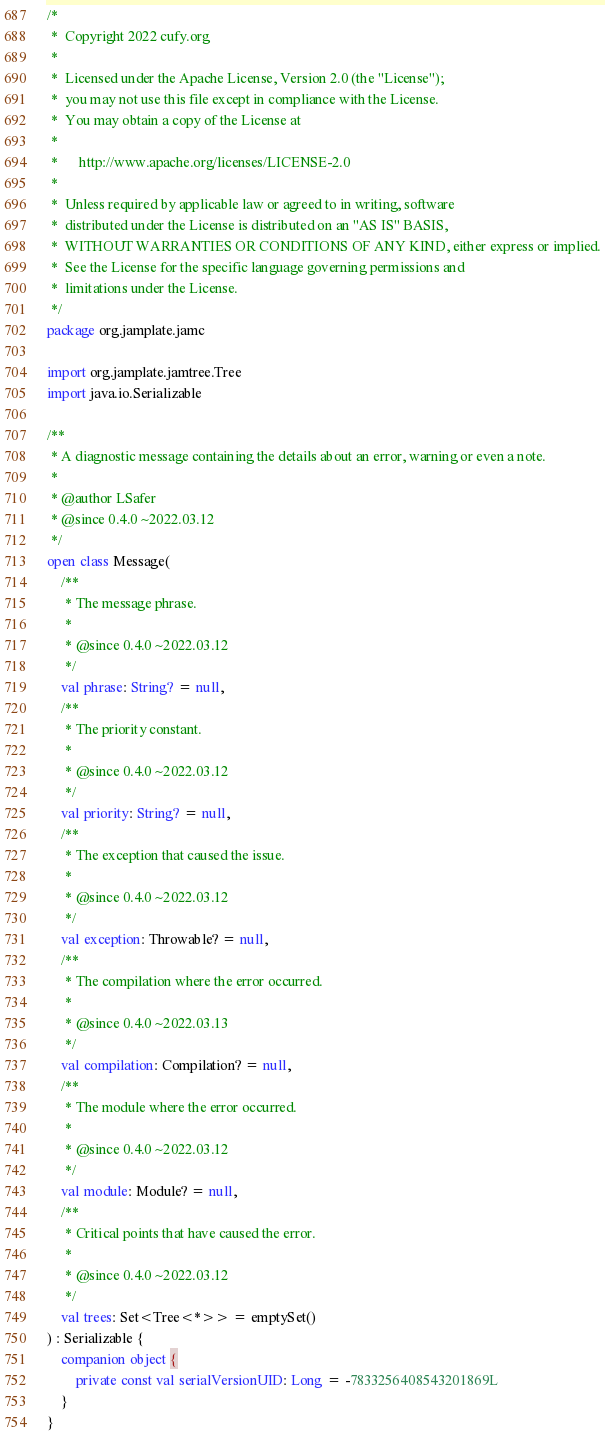<code> <loc_0><loc_0><loc_500><loc_500><_Kotlin_>/*
 *	Copyright 2022 cufy.org
 *
 *	Licensed under the Apache License, Version 2.0 (the "License");
 *	you may not use this file except in compliance with the License.
 *	You may obtain a copy of the License at
 *
 *	    http://www.apache.org/licenses/LICENSE-2.0
 *
 *	Unless required by applicable law or agreed to in writing, software
 *	distributed under the License is distributed on an "AS IS" BASIS,
 *	WITHOUT WARRANTIES OR CONDITIONS OF ANY KIND, either express or implied.
 *	See the License for the specific language governing permissions and
 *	limitations under the License.
 */
package org.jamplate.jamc

import org.jamplate.jamtree.Tree
import java.io.Serializable

/**
 * A diagnostic message containing the details about an error, warning or even a note.
 *
 * @author LSafer
 * @since 0.4.0 ~2022.03.12
 */
open class Message(
    /**
     * The message phrase.
     *
     * @since 0.4.0 ~2022.03.12
     */
    val phrase: String? = null,
    /**
     * The priority constant.
     *
     * @since 0.4.0 ~2022.03.12
     */
    val priority: String? = null,
    /**
     * The exception that caused the issue.
     *
     * @since 0.4.0 ~2022.03.12
     */
    val exception: Throwable? = null,
    /**
     * The compilation where the error occurred.
     *
     * @since 0.4.0 ~2022.03.13
     */
    val compilation: Compilation? = null,
    /**
     * The module where the error occurred.
     *
     * @since 0.4.0 ~2022.03.12
     */
    val module: Module? = null,
    /**
     * Critical points that have caused the error.
     *
     * @since 0.4.0 ~2022.03.12
     */
    val trees: Set<Tree<*>> = emptySet()
) : Serializable {
    companion object {
        private const val serialVersionUID: Long = -7833256408543201869L
    }
}
</code> 